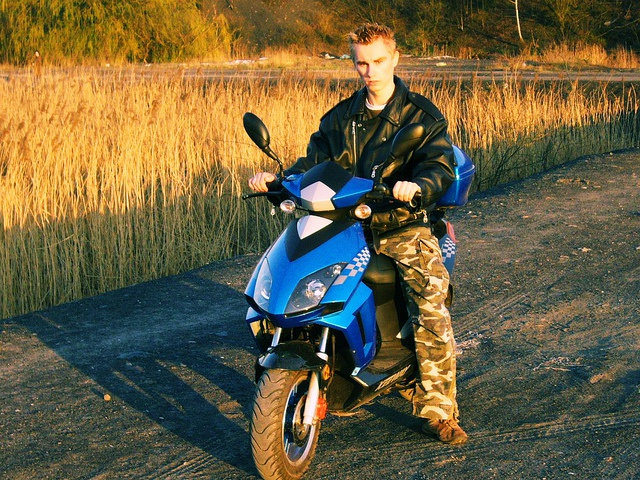Describe the objects in this image and their specific colors. I can see motorcycle in olive, black, blue, lightblue, and lightgray tones and people in olive, black, khaki, and orange tones in this image. 